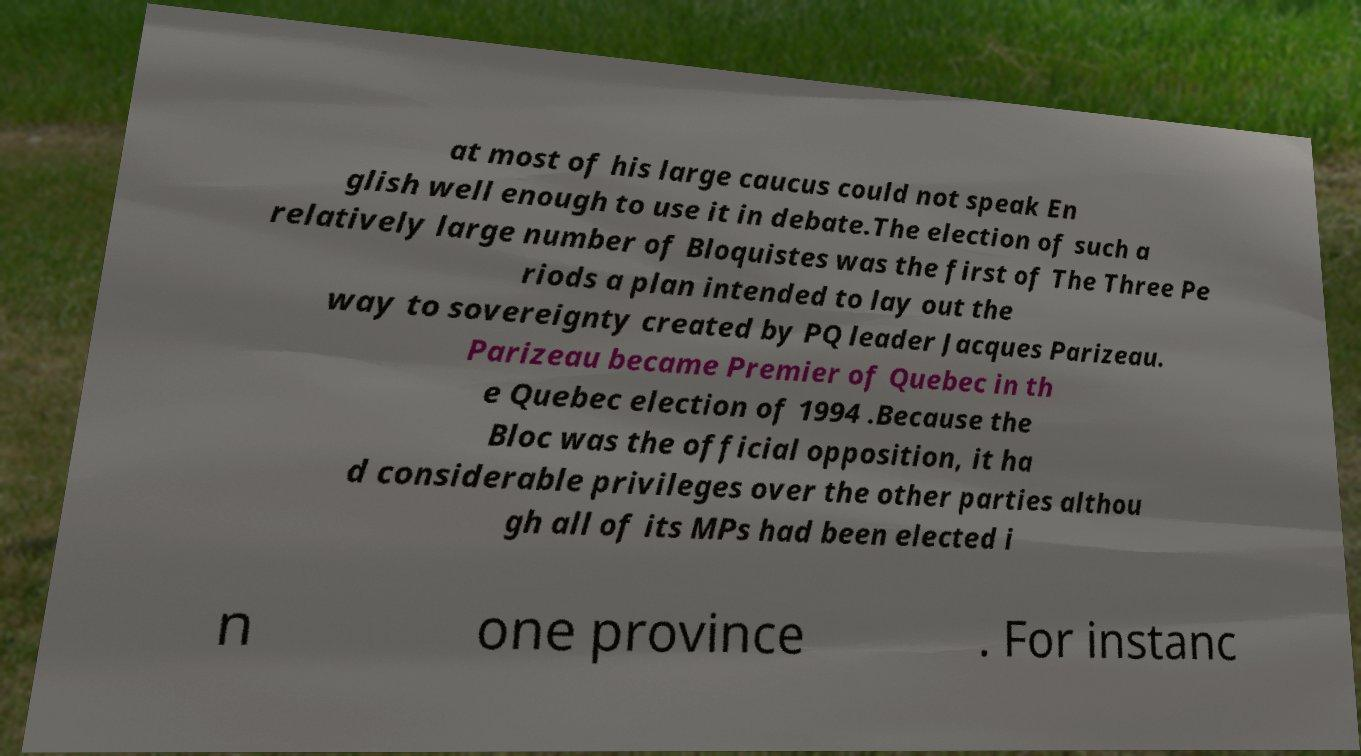Please identify and transcribe the text found in this image. at most of his large caucus could not speak En glish well enough to use it in debate.The election of such a relatively large number of Bloquistes was the first of The Three Pe riods a plan intended to lay out the way to sovereignty created by PQ leader Jacques Parizeau. Parizeau became Premier of Quebec in th e Quebec election of 1994 .Because the Bloc was the official opposition, it ha d considerable privileges over the other parties althou gh all of its MPs had been elected i n one province . For instanc 